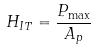<formula> <loc_0><loc_0><loc_500><loc_500>H _ { I T } = \frac { P _ { \max } } { A _ { p } }</formula> 